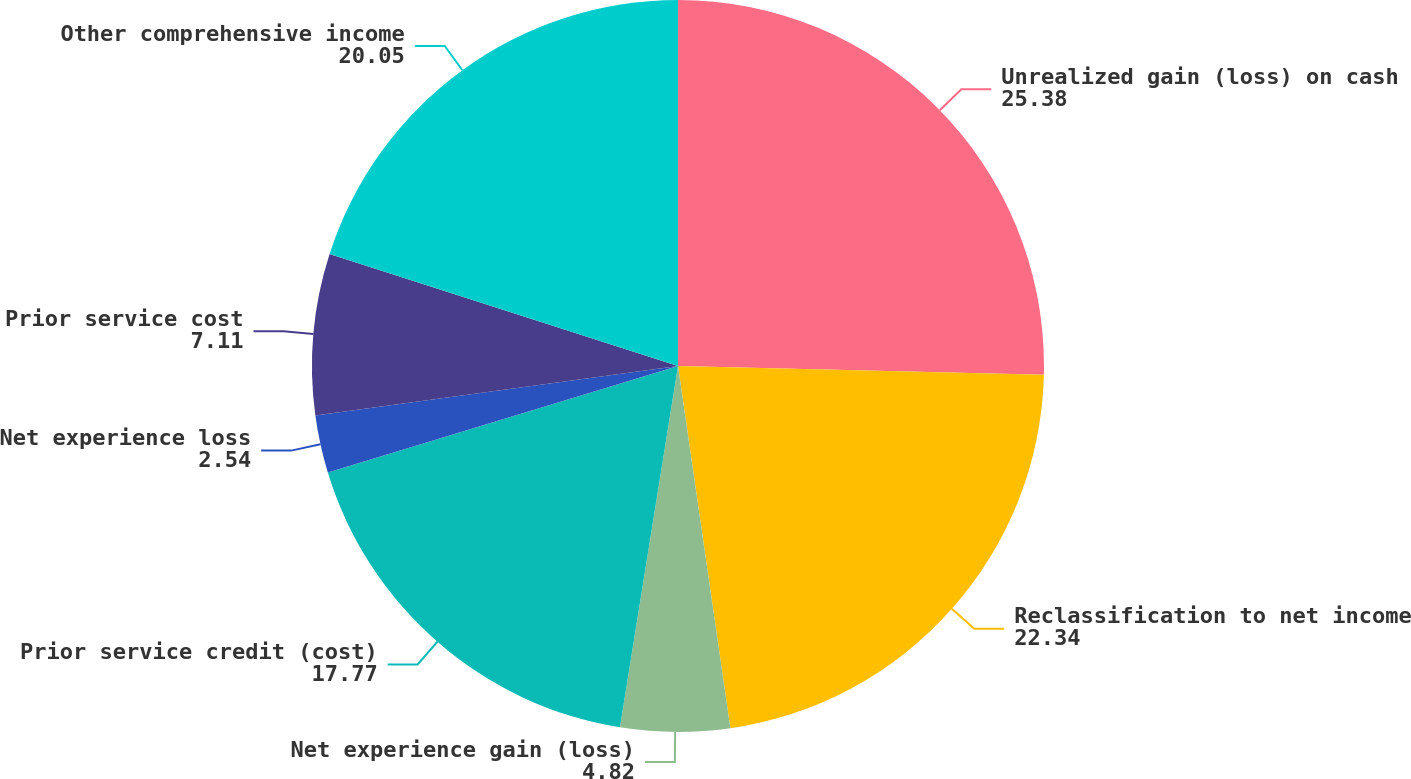Convert chart to OTSL. <chart><loc_0><loc_0><loc_500><loc_500><pie_chart><fcel>Unrealized gain (loss) on cash<fcel>Reclassification to net income<fcel>Net experience gain (loss)<fcel>Prior service credit (cost)<fcel>Net experience loss<fcel>Prior service cost<fcel>Other comprehensive income<nl><fcel>25.38%<fcel>22.34%<fcel>4.82%<fcel>17.77%<fcel>2.54%<fcel>7.11%<fcel>20.05%<nl></chart> 